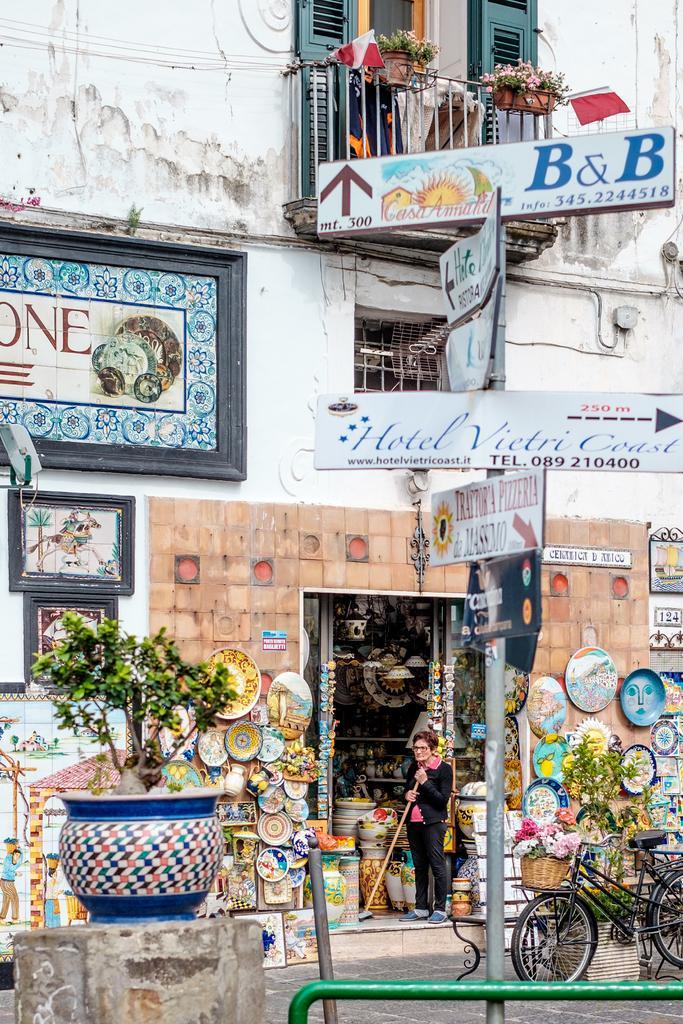Please provide a concise description of this image. In this image there is a building. At the bottom there is a store and we can see things placed in the store. There is a basket. On the left we can see a houseplant. There are poles. We can see boards. On the right there is a bicycle. In the center there is a person standing. 